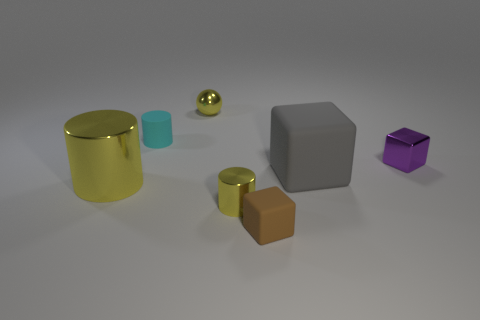There is a tiny yellow object that is the same shape as the large yellow metallic object; what material is it?
Provide a succinct answer. Metal. Is the number of spheres in front of the large metallic object greater than the number of purple metallic blocks that are in front of the purple shiny block?
Provide a short and direct response. No. There is a purple shiny object that is the same size as the metal sphere; what is its shape?
Offer a terse response. Cube. What number of things are rubber cylinders or shiny things to the right of the rubber cylinder?
Offer a terse response. 4. Does the big matte thing have the same color as the tiny shiny cylinder?
Provide a succinct answer. No. What number of objects are left of the brown thing?
Keep it short and to the point. 4. The tiny cylinder that is made of the same material as the yellow ball is what color?
Make the answer very short. Yellow. What number of metal things are tiny cyan cubes or big cubes?
Provide a succinct answer. 0. Are the gray thing and the small yellow ball made of the same material?
Offer a very short reply. No. The tiny rubber object that is behind the small brown thing has what shape?
Give a very brief answer. Cylinder. 